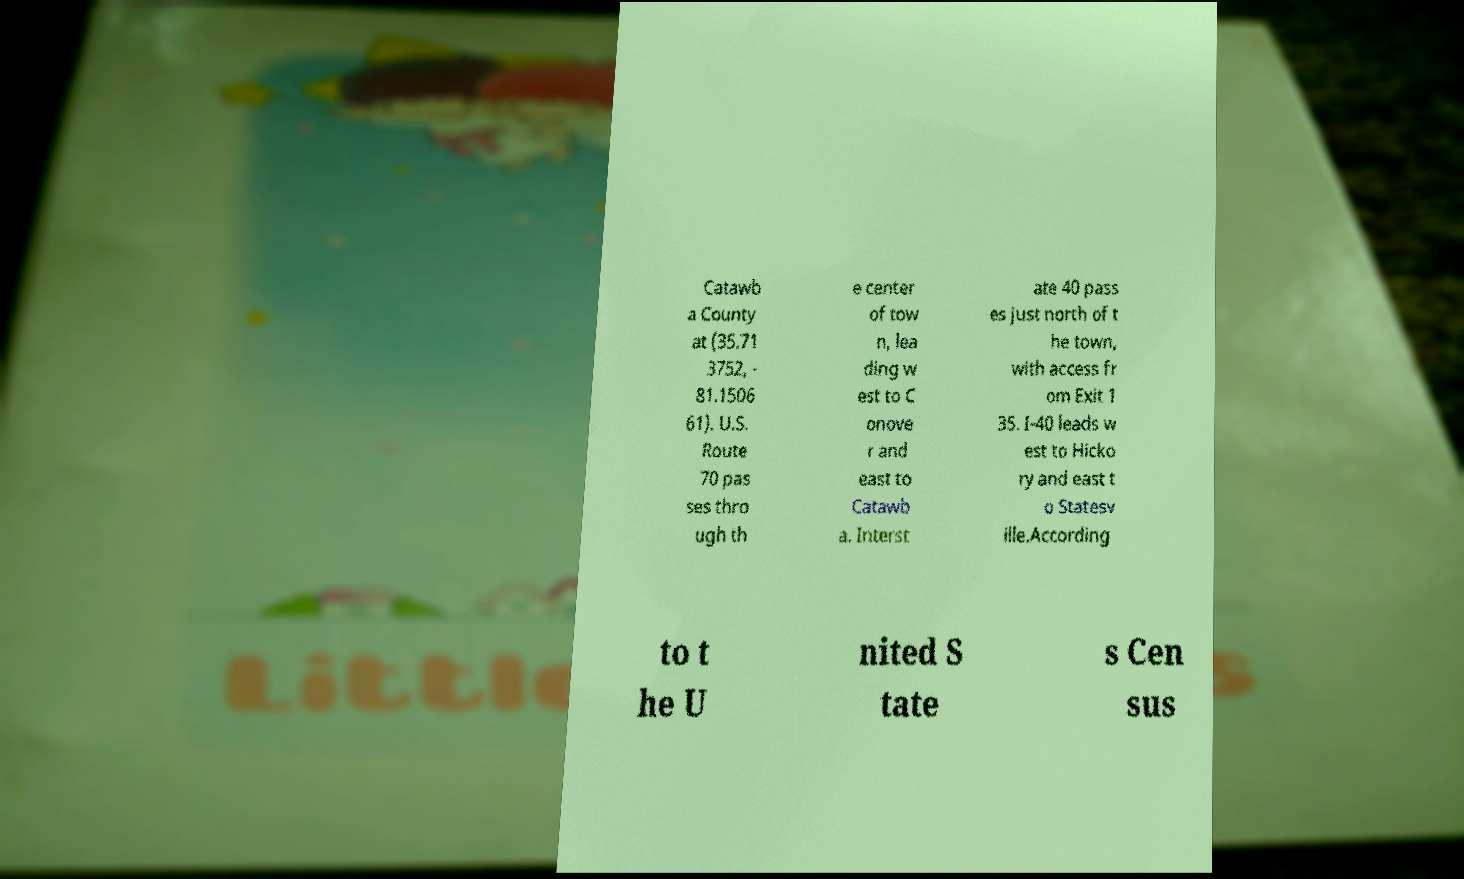I need the written content from this picture converted into text. Can you do that? Catawb a County at (35.71 3752, - 81.1506 61). U.S. Route 70 pas ses thro ugh th e center of tow n, lea ding w est to C onove r and east to Catawb a. Interst ate 40 pass es just north of t he town, with access fr om Exit 1 35. I-40 leads w est to Hicko ry and east t o Statesv ille.According to t he U nited S tate s Cen sus 